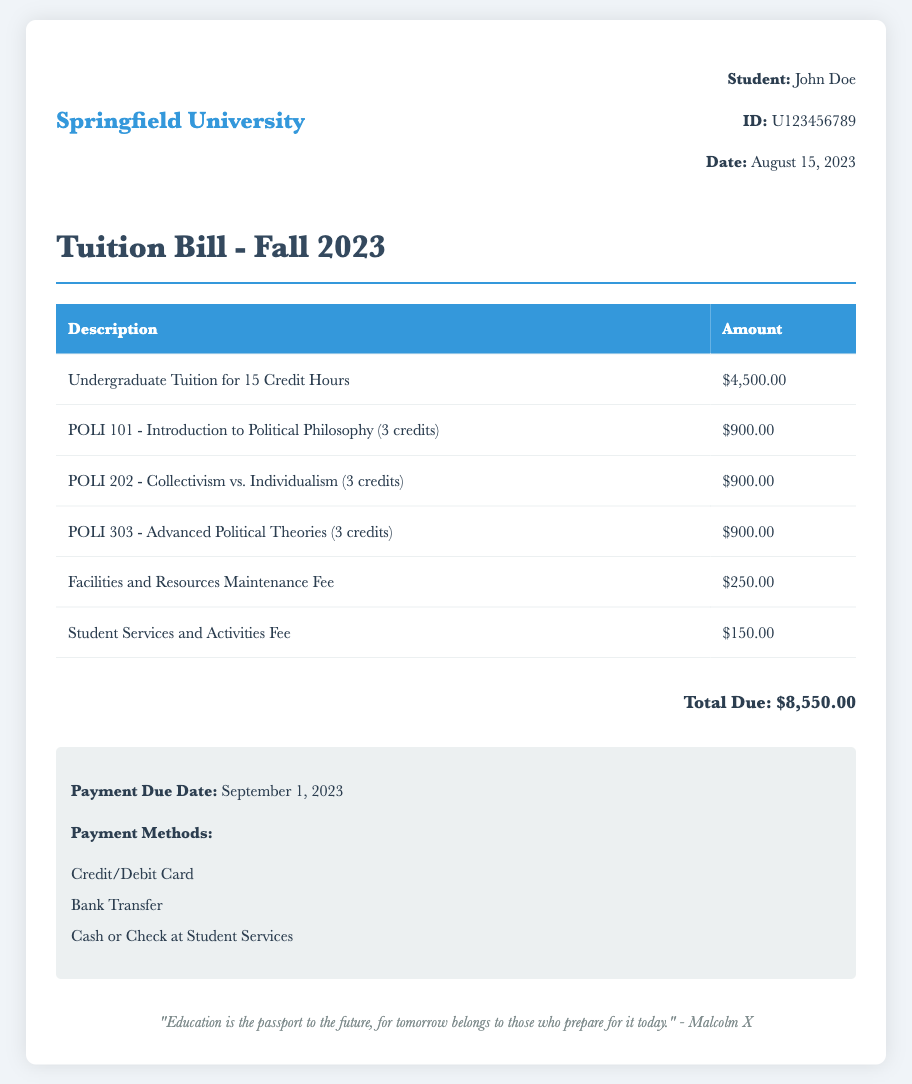What is the name of the university? The document presents a tuition bill from Springfield University.
Answer: Springfield University Who is the student listed on the bill? The document shows that the student associated with the bill is John Doe.
Answer: John Doe What is the total amount due? The bill states the total amount due is $8,550.00.
Answer: $8,550.00 When is the payment due date? According to the document, the payment due date is September 1, 2023.
Answer: September 1, 2023 How many credit hours are included in the undergraduate tuition charge? The document indicates that the undergraduate tuition charge covers 15 credit hours.
Answer: 15 Credit Hours What is the fee for facilities and resources maintenance? The document specifies that the facilities and resources maintenance fee is $250.00.
Answer: $250.00 How many political philosophy courses are listed in the bill? The document lists three political philosophy courses with individual charges.
Answer: Three What are the payment methods available? The document outlines payment methods including Credit/Debit Card, Bank Transfer, and Cash or Check at Student Services.
Answer: Credit/Debit Card, Bank Transfer, Cash or Check What is the charge for POLI 202? The document shows that the charge for POLI 202 is $900.00.
Answer: $900.00 